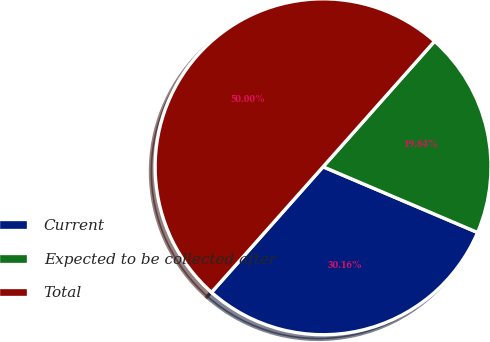Convert chart to OTSL. <chart><loc_0><loc_0><loc_500><loc_500><pie_chart><fcel>Current<fcel>Expected to be collected after<fcel>Total<nl><fcel>30.16%<fcel>19.84%<fcel>50.0%<nl></chart> 